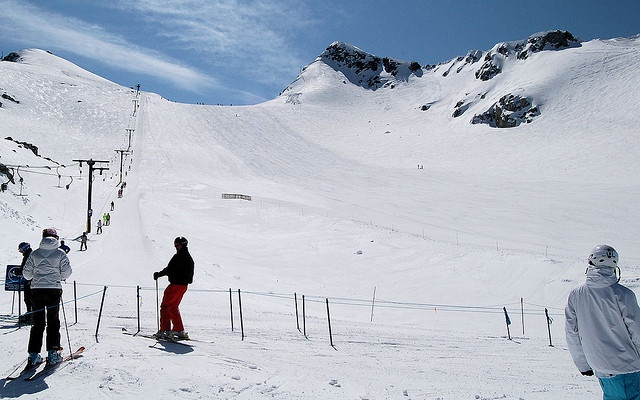Describe the objects in this image and their specific colors. I can see people in darkgray and gray tones, people in darkgray, black, gray, and lightgray tones, people in darkgray, black, lightgray, maroon, and gray tones, skis in darkgray, black, navy, and gray tones, and people in darkgray, black, gray, lightgray, and navy tones in this image. 